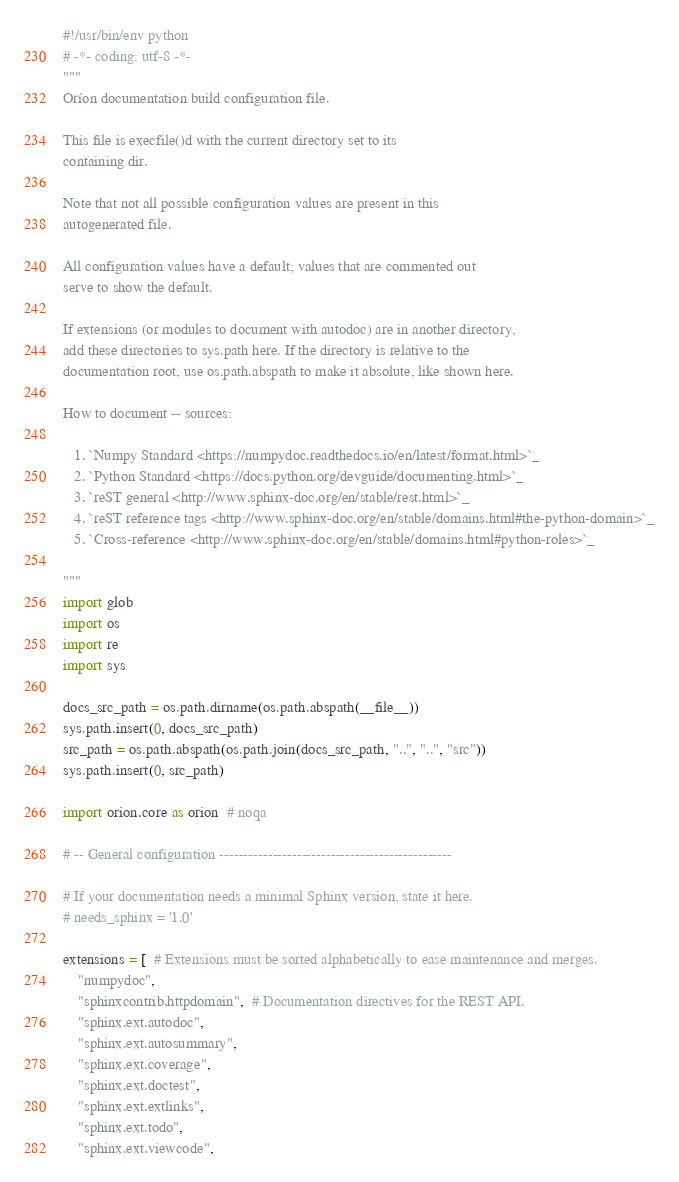<code> <loc_0><loc_0><loc_500><loc_500><_Python_>#!/usr/bin/env python
# -*- coding: utf-8 -*-
"""
Oríon documentation build configuration file.

This file is execfile()d with the current directory set to its
containing dir.

Note that not all possible configuration values are present in this
autogenerated file.

All configuration values have a default; values that are commented out
serve to show the default.

If extensions (or modules to document with autodoc) are in another directory,
add these directories to sys.path here. If the directory is relative to the
documentation root, use os.path.abspath to make it absolute, like shown here.

How to document -- sources:

   1. `Numpy Standard <https://numpydoc.readthedocs.io/en/latest/format.html>`_
   2. `Python Standard <https://docs.python.org/devguide/documenting.html>`_
   3. `reST general <http://www.sphinx-doc.org/en/stable/rest.html>`_
   4. `reST reference tags <http://www.sphinx-doc.org/en/stable/domains.html#the-python-domain>`_
   5. `Cross-reference <http://www.sphinx-doc.org/en/stable/domains.html#python-roles>`_

"""
import glob
import os
import re
import sys

docs_src_path = os.path.dirname(os.path.abspath(__file__))
sys.path.insert(0, docs_src_path)
src_path = os.path.abspath(os.path.join(docs_src_path, "..", "..", "src"))
sys.path.insert(0, src_path)

import orion.core as orion  # noqa

# -- General configuration ------------------------------------------------

# If your documentation needs a minimal Sphinx version, state it here.
# needs_sphinx = '1.0'

extensions = [  # Extensions must be sorted alphabetically to ease maintenance and merges.
    "numpydoc",
    "sphinxcontrib.httpdomain",  # Documentation directives for the REST API.
    "sphinx.ext.autodoc",
    "sphinx.ext.autosummary",
    "sphinx.ext.coverage",
    "sphinx.ext.doctest",
    "sphinx.ext.extlinks",
    "sphinx.ext.todo",
    "sphinx.ext.viewcode",</code> 